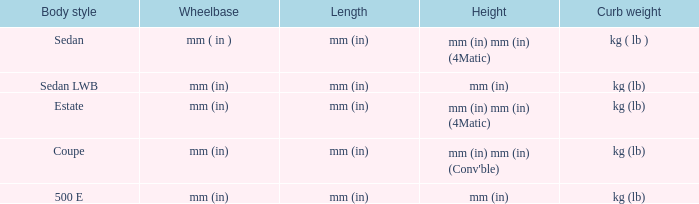Can you parse all the data within this table? {'header': ['Body style', 'Wheelbase', 'Length', 'Height', 'Curb weight'], 'rows': [['Sedan', 'mm ( in )', 'mm (in)', 'mm (in) mm (in) (4Matic)', 'kg ( lb )'], ['Sedan LWB', 'mm (in)', 'mm (in)', 'mm (in)', 'kg (lb)'], ['Estate', 'mm (in)', 'mm (in)', 'mm (in) mm (in) (4Matic)', 'kg (lb)'], ['Coupe', 'mm (in)', 'mm (in)', "mm (in) mm (in) (Conv'ble)", 'kg (lb)'], ['500 E', 'mm (in)', 'mm (in)', 'mm (in)', 'kg (lb)']]} What's the curb weight of the model with a wheelbase of mm (in) and height of mm (in) mm (in) (4Matic)? Kg ( lb ), kg (lb). 